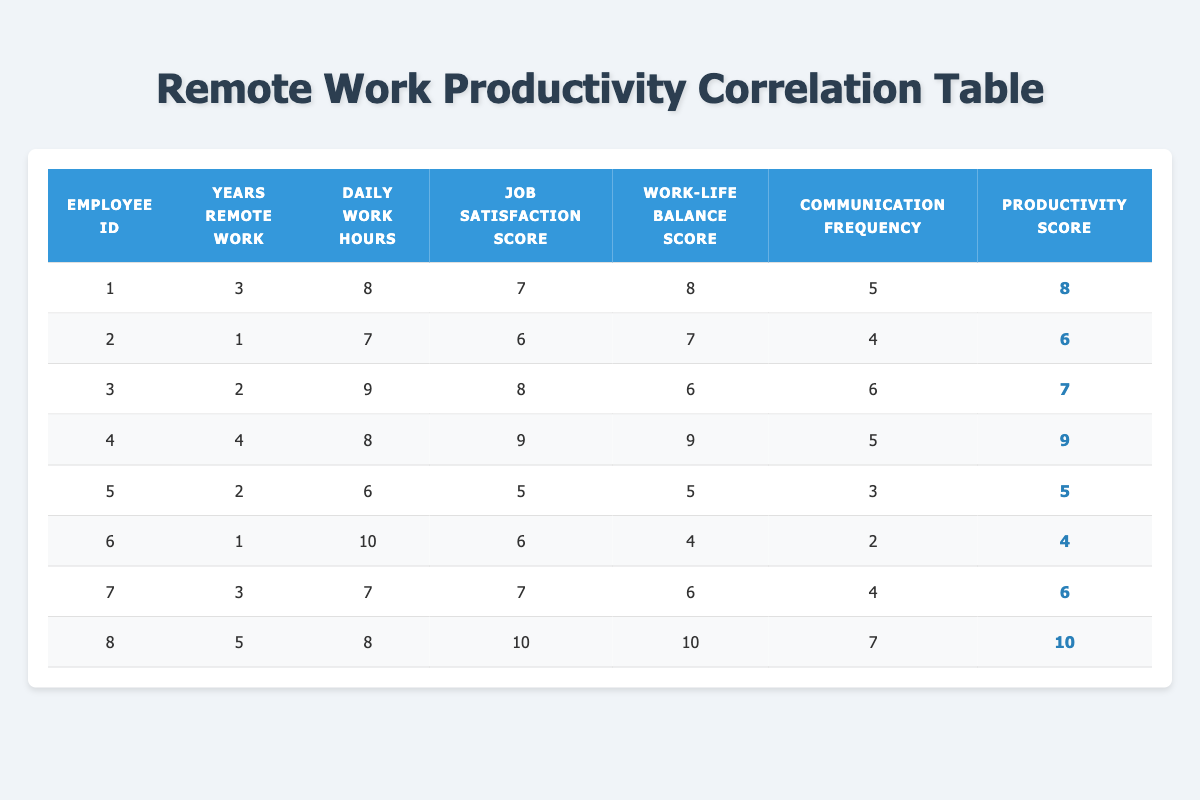What is the productivity score of Employee ID 4? By looking at the table, I can find the row that corresponds to Employee ID 4. In that row, the productivity score is clearly stated as 9.
Answer: 9 What is the average job satisfaction score of all employees? To calculate the average job satisfaction score, I first sum all the individual scores: (7 + 6 + 8 + 9 + 5 + 6 + 7 + 10) = 58. There are 8 employees, so the average is 58/8 = 7.25.
Answer: 7.25 Is the work-life balance score for Employee ID 6 greater than 5? By checking the table, the work-life balance score for Employee ID 6 is 4. Since 4 is not greater than 5, the answer is no.
Answer: No Which employee has the highest communication frequency? Looking through the table, Employee ID 8 has the highest communication frequency score of 7. No other employee exceeds this score.
Answer: Employee ID 8 What is the difference between the highest and lowest productivity scores in the table? The highest productivity score is 10 (Employee ID 8), and the lowest productivity score is 4 (Employee ID 6). The difference is calculated as 10 - 4 = 6.
Answer: 6 How many employees have more than 4 years of remote work experience and have a productivity score of 8 or higher? From the data, only Employee ID 4 and Employee ID 8 meet both criteria: Employee ID 4 has 4 years of remote work experience and a productivity score of 9, while Employee ID 8 has 5 years and a score of 10. So, there are 2 employees.
Answer: 2 Is there an employee who works 10 hours a day and has a job satisfaction score of 6? Checking the table, Employee ID 6 works 10 hours a day and also has a job satisfaction score of 6. Therefore, the answer is yes.
Answer: Yes What is the maximum value of daily work hours among employees who have worked remotely for 3 years or more? Employees with 3 or more years of remote work experience are Employee ID 1 (8 hours), Employee ID 4 (8 hours), and Employee ID 8 (8 hours). The maximum is 8 hours.
Answer: 8 